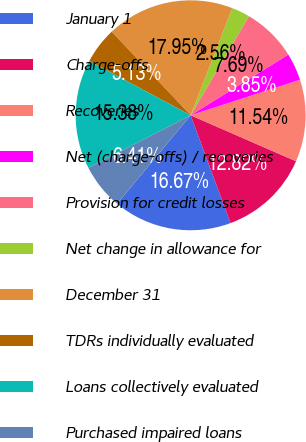Convert chart. <chart><loc_0><loc_0><loc_500><loc_500><pie_chart><fcel>January 1<fcel>Charge-offs<fcel>Recoveries<fcel>Net (charge-offs) / recoveries<fcel>Provision for credit losses<fcel>Net change in allowance for<fcel>December 31<fcel>TDRs individually evaluated<fcel>Loans collectively evaluated<fcel>Purchased impaired loans<nl><fcel>16.67%<fcel>12.82%<fcel>11.54%<fcel>3.85%<fcel>7.69%<fcel>2.56%<fcel>17.95%<fcel>5.13%<fcel>15.38%<fcel>6.41%<nl></chart> 